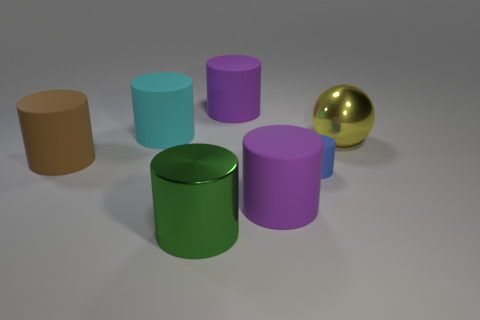There is a ball that is the same size as the green metallic object; what is its color?
Ensure brevity in your answer.  Yellow. Are there any big cylinders?
Your answer should be very brief. Yes. What is the shape of the big metallic thing that is in front of the large yellow shiny object?
Offer a very short reply. Cylinder. What number of cylinders are behind the metal cylinder and to the right of the big cyan object?
Provide a short and direct response. 3. Are there any cyan spheres that have the same material as the green object?
Offer a very short reply. No. What number of cylinders are either shiny things or big gray metallic objects?
Your answer should be very brief. 1. What size is the green metallic thing?
Keep it short and to the point. Large. There is a big ball; how many purple rubber objects are behind it?
Ensure brevity in your answer.  1. How big is the purple thing behind the purple matte thing in front of the large yellow thing?
Offer a terse response. Large. Is the shape of the large metallic object that is behind the green thing the same as the purple thing that is behind the cyan object?
Your response must be concise. No. 